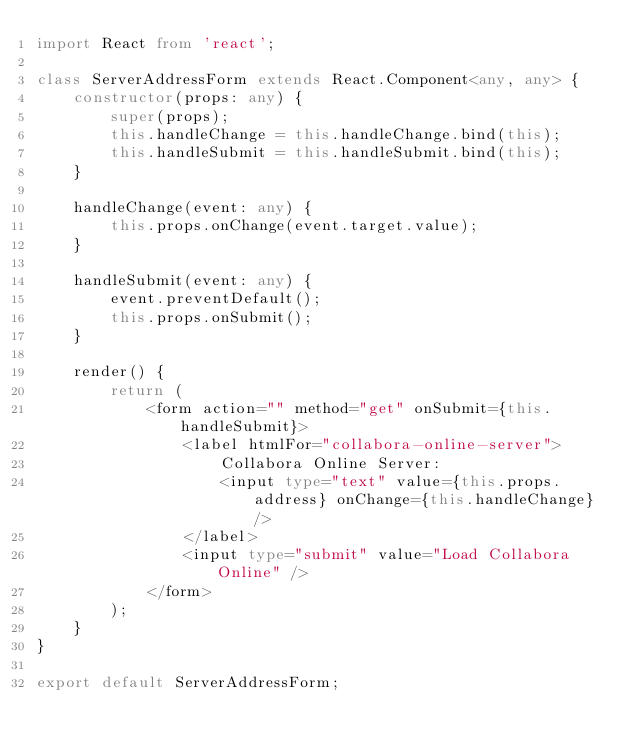Convert code to text. <code><loc_0><loc_0><loc_500><loc_500><_TypeScript_>import React from 'react';

class ServerAddressForm extends React.Component<any, any> {
    constructor(props: any) {
        super(props);
        this.handleChange = this.handleChange.bind(this);
        this.handleSubmit = this.handleSubmit.bind(this);
    }

    handleChange(event: any) {
        this.props.onChange(event.target.value);
    }

    handleSubmit(event: any) {
        event.preventDefault();
        this.props.onSubmit();
    }

    render() {
        return (
            <form action="" method="get" onSubmit={this.handleSubmit}>
                <label htmlFor="collabora-online-server">
                    Collabora Online Server:
                    <input type="text" value={this.props.address} onChange={this.handleChange} />
                </label>
                <input type="submit" value="Load Collabora Online" />
            </form>
        );
    }
}

export default ServerAddressForm;
</code> 